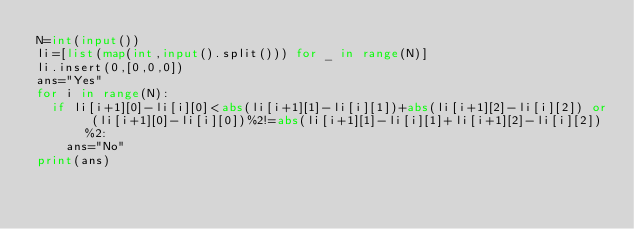Convert code to text. <code><loc_0><loc_0><loc_500><loc_500><_Python_>N=int(input())
li=[list(map(int,input().split())) for _ in range(N)]
li.insert(0,[0,0,0])
ans="Yes"
for i in range(N):
  if li[i+1][0]-li[i][0]<abs(li[i+1][1]-li[i][1])+abs(li[i+1][2]-li[i][2]) or (li[i+1][0]-li[i][0])%2!=abs(li[i+1][1]-li[i][1]+li[i+1][2]-li[i][2])%2:
    ans="No"
print(ans)</code> 